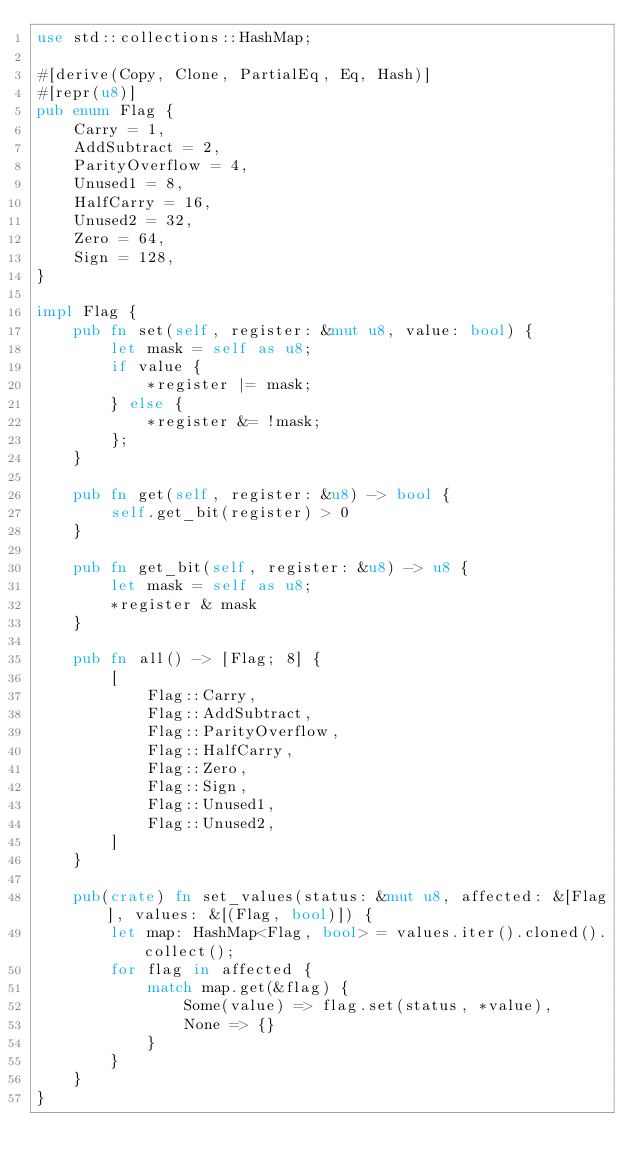Convert code to text. <code><loc_0><loc_0><loc_500><loc_500><_Rust_>use std::collections::HashMap;

#[derive(Copy, Clone, PartialEq, Eq, Hash)]
#[repr(u8)]
pub enum Flag {
    Carry = 1,
    AddSubtract = 2,
    ParityOverflow = 4,
    Unused1 = 8,
    HalfCarry = 16,
    Unused2 = 32,
    Zero = 64,
    Sign = 128,
}

impl Flag {
    pub fn set(self, register: &mut u8, value: bool) {
        let mask = self as u8;
        if value {
            *register |= mask;
        } else {
            *register &= !mask;
        };
    }

    pub fn get(self, register: &u8) -> bool {
        self.get_bit(register) > 0
    }

    pub fn get_bit(self, register: &u8) -> u8 {
        let mask = self as u8;
        *register & mask
    }

    pub fn all() -> [Flag; 8] {
        [
            Flag::Carry,
            Flag::AddSubtract,
            Flag::ParityOverflow,
            Flag::HalfCarry,
            Flag::Zero,
            Flag::Sign,
            Flag::Unused1,
            Flag::Unused2,
        ]
    }

    pub(crate) fn set_values(status: &mut u8, affected: &[Flag], values: &[(Flag, bool)]) {
        let map: HashMap<Flag, bool> = values.iter().cloned().collect();
        for flag in affected {
            match map.get(&flag) {
                Some(value) => flag.set(status, *value),
                None => {}
            }
        }
    }
}
</code> 